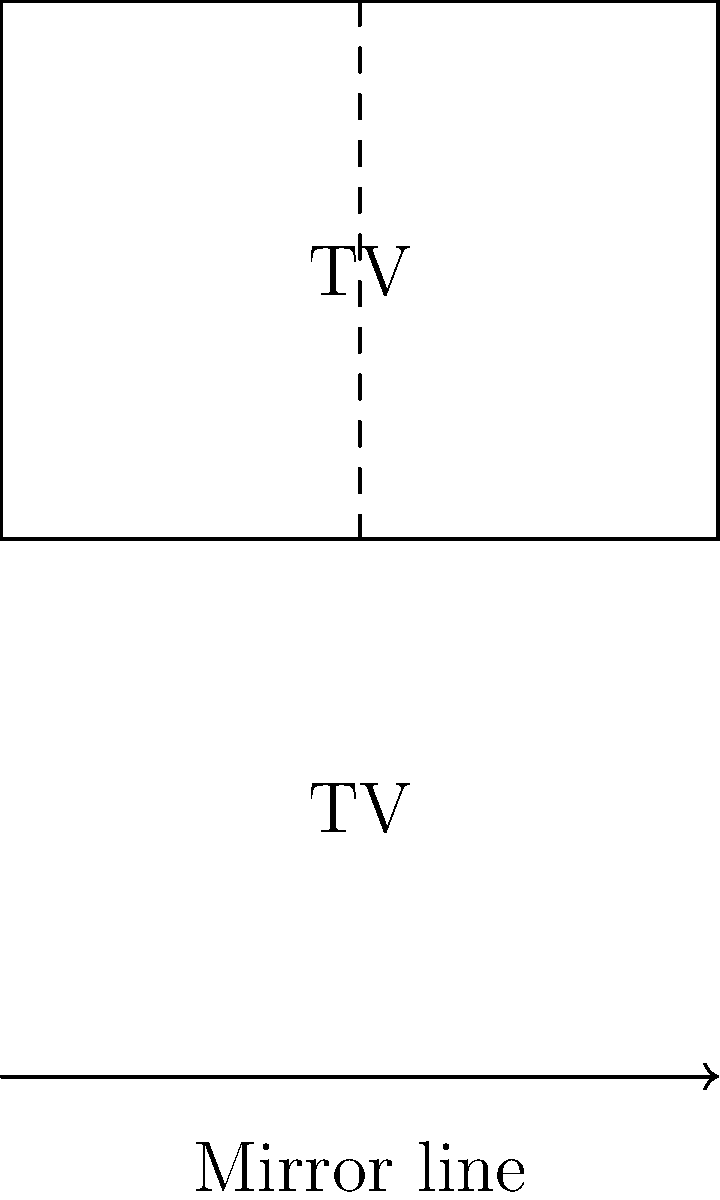A classic TV show logo is reflected across a mirror line as shown in the diagram. If the original logo is 3 units tall and 4 units wide, what are the dimensions of the entire image (including both the original and reflected logo)? To solve this problem, we need to understand the concept of reflection in transformational geometry. Here's a step-by-step explanation:

1. The original logo is 3 units tall and 4 units wide.

2. When an object is reflected across a line, the reflected image is congruent to the original object. This means it has the same size and shape.

3. The reflection appears on the opposite side of the mirror line, at an equal distance from the line.

4. In this case, the reflection is directly below the original logo.

5. To find the total height of the image:
   - Original logo height: 3 units
   - Reflected logo height: 3 units
   - Total height: $3 + 3 = 6$ units

6. The width of the image remains unchanged, as the reflection is vertically aligned with the original:
   - Width: 4 units

Therefore, the dimensions of the entire image (including both the original and reflected logo) are 6 units tall and 4 units wide.
Answer: $6 \times 4$ units 